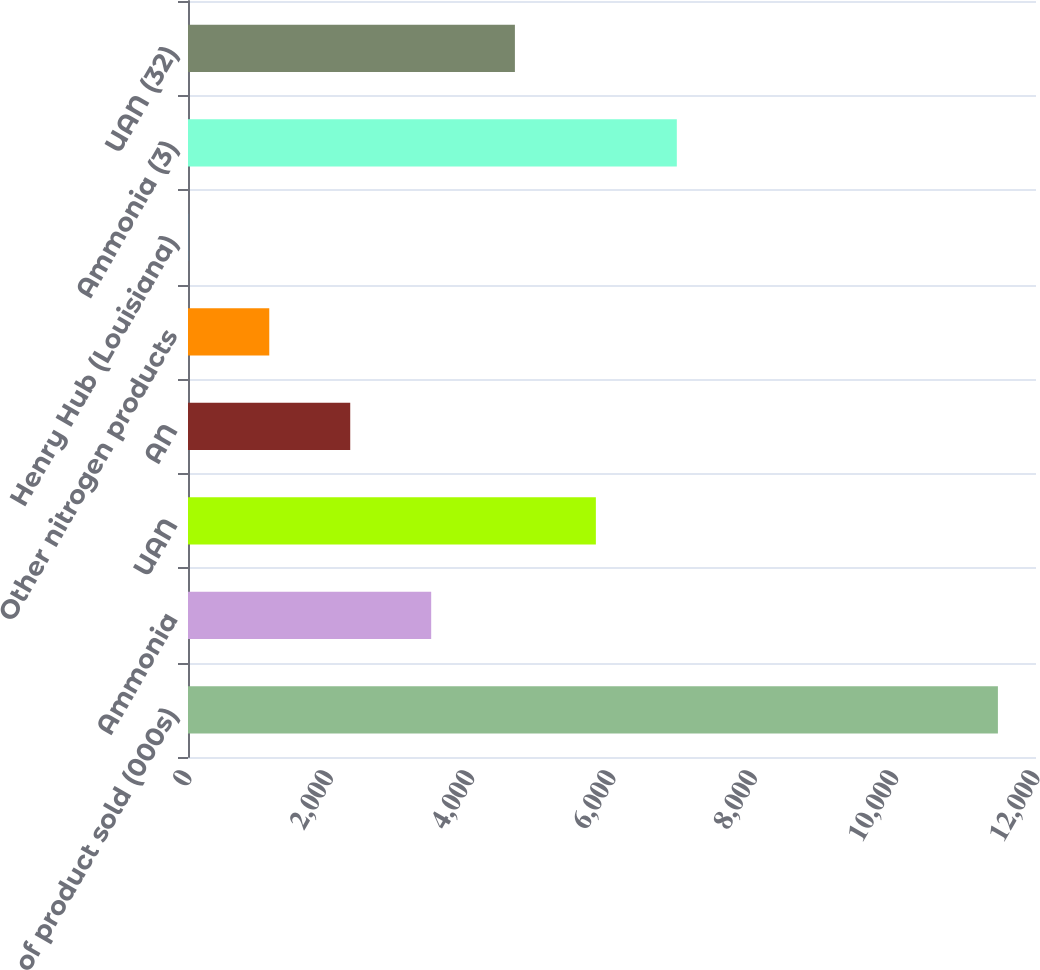Convert chart. <chart><loc_0><loc_0><loc_500><loc_500><bar_chart><fcel>Tons of product sold (000s)<fcel>Ammonia<fcel>UAN<fcel>AN<fcel>Other nitrogen products<fcel>Henry Hub (Louisiana)<fcel>Ammonia (3)<fcel>UAN (32)<nl><fcel>11461<fcel>3441.35<fcel>5771.66<fcel>2295.69<fcel>1150.03<fcel>4.37<fcel>6917.32<fcel>4626<nl></chart> 